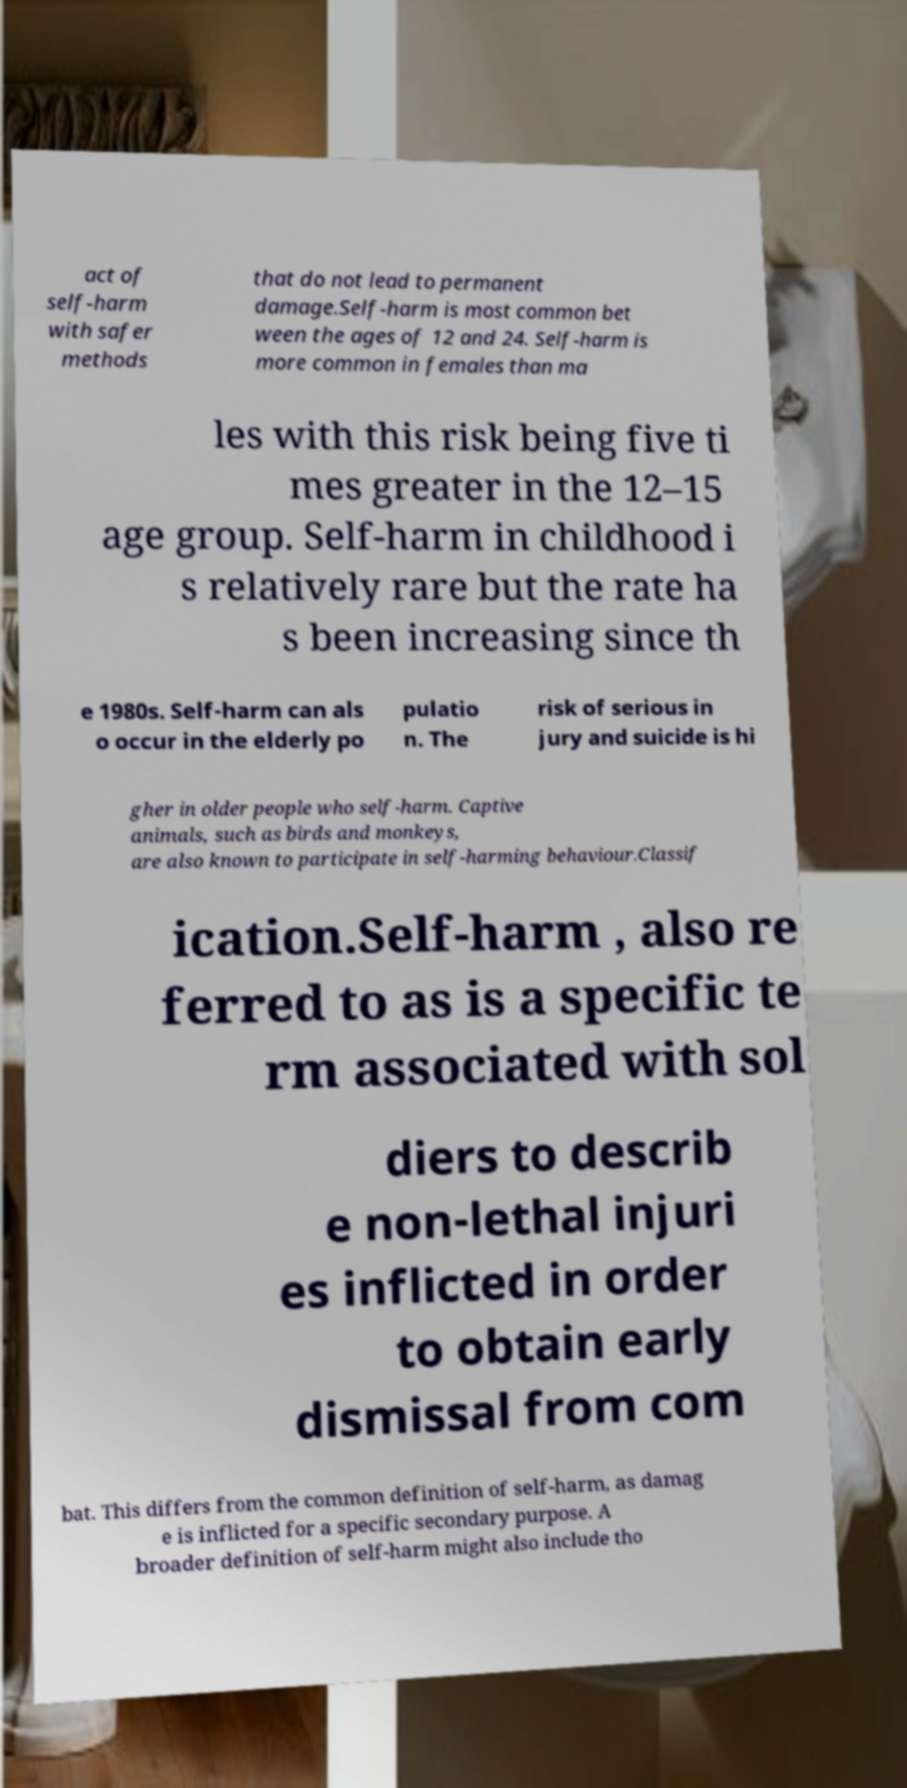For documentation purposes, I need the text within this image transcribed. Could you provide that? act of self-harm with safer methods that do not lead to permanent damage.Self-harm is most common bet ween the ages of 12 and 24. Self-harm is more common in females than ma les with this risk being five ti mes greater in the 12–15 age group. Self-harm in childhood i s relatively rare but the rate ha s been increasing since th e 1980s. Self-harm can als o occur in the elderly po pulatio n. The risk of serious in jury and suicide is hi gher in older people who self-harm. Captive animals, such as birds and monkeys, are also known to participate in self-harming behaviour.Classif ication.Self-harm , also re ferred to as is a specific te rm associated with sol diers to describ e non-lethal injuri es inflicted in order to obtain early dismissal from com bat. This differs from the common definition of self-harm, as damag e is inflicted for a specific secondary purpose. A broader definition of self-harm might also include tho 